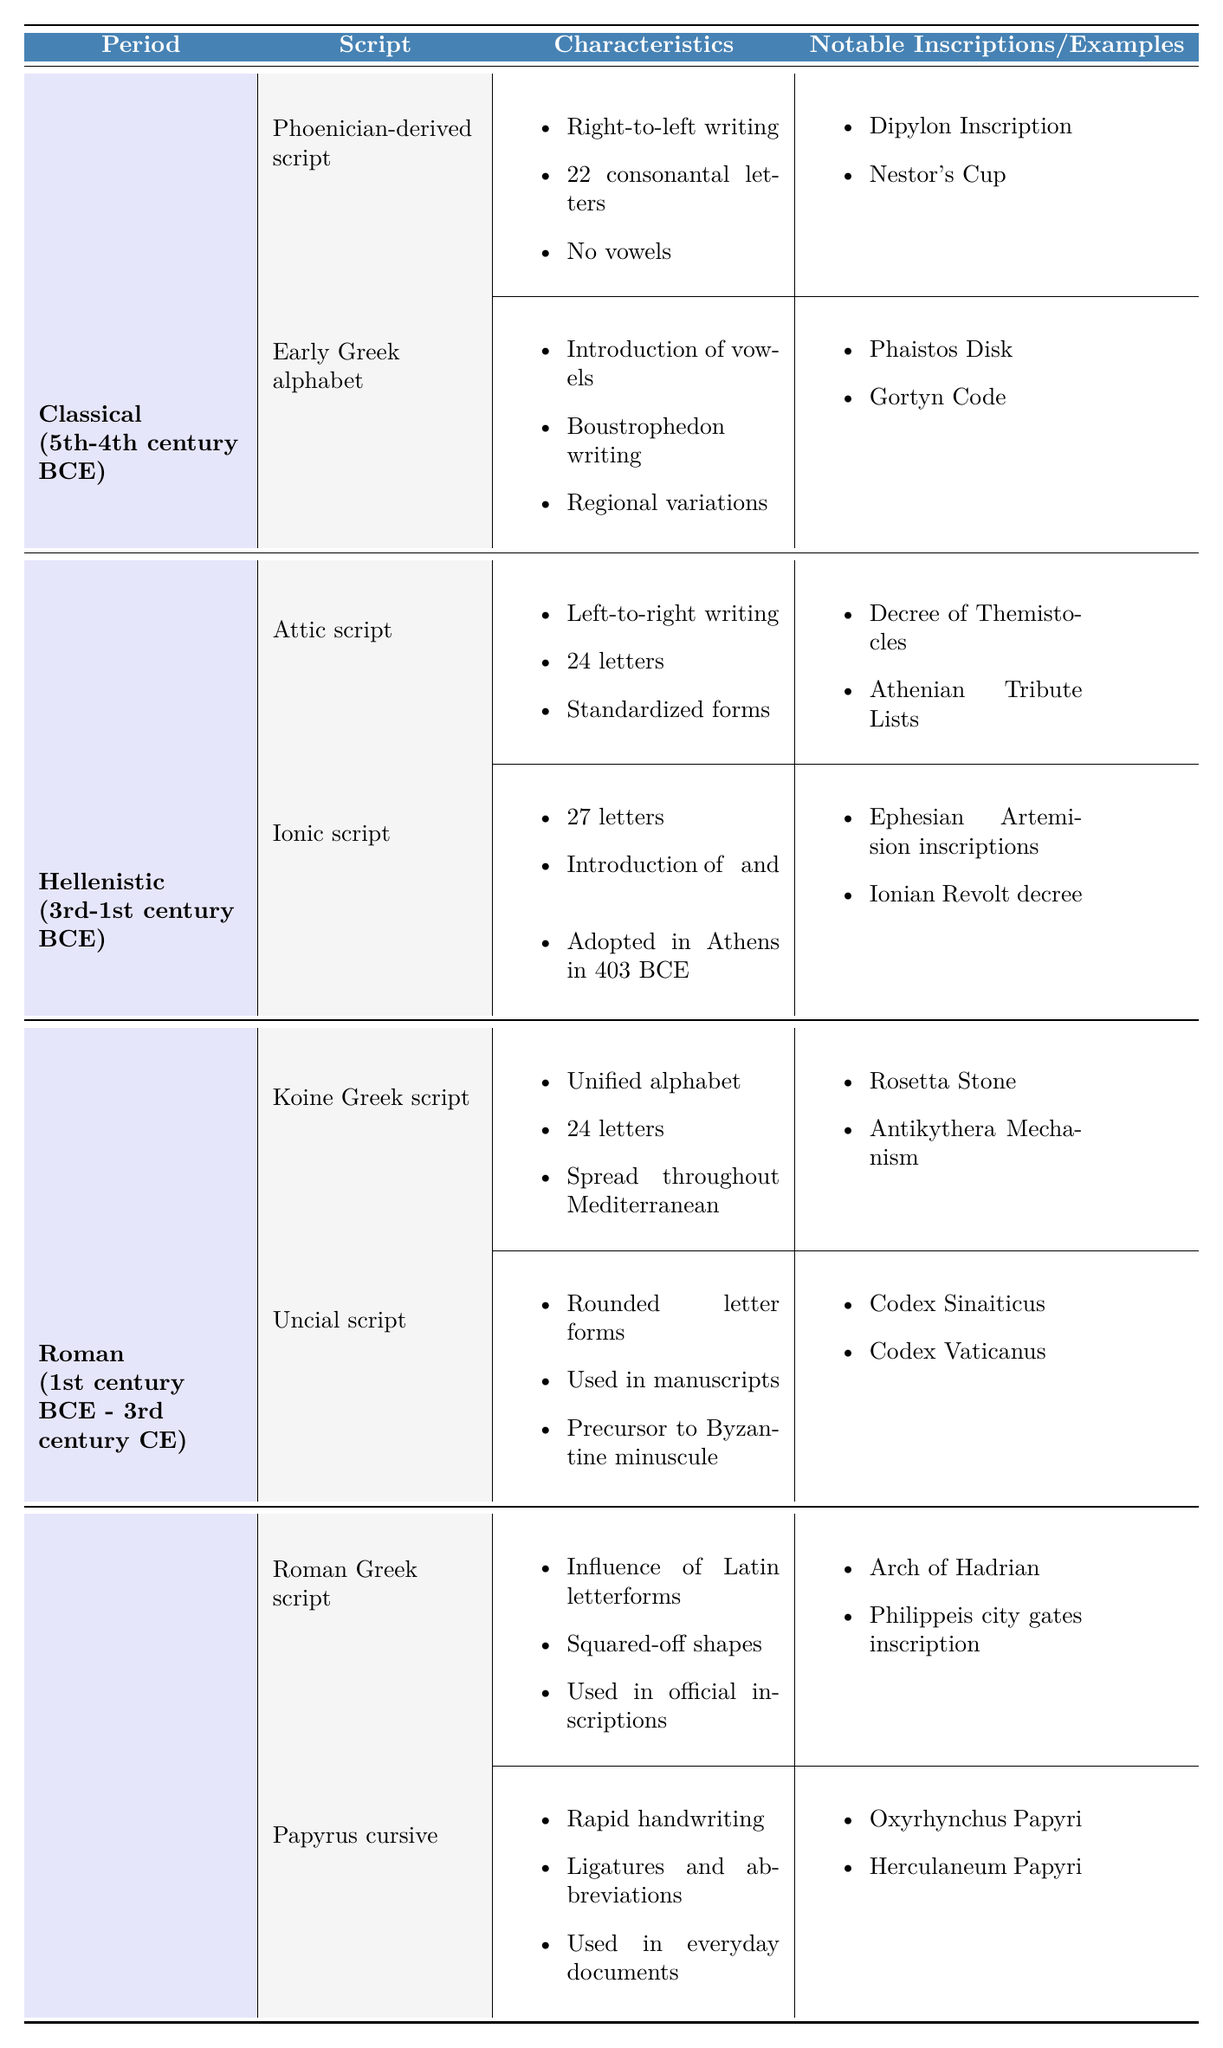What is the period for the "Ionic script"? The table lists the "Ionic script" under the "Classical (5th-4th century BCE)" period.
Answer: Classical (5th-4th century BCE) Which script introduced vowels? The "Early Greek alphabet" is noted for introducing vowels in its writing system.
Answer: Early Greek alphabet How many letters does the "Attic script" have? The table indicates that the "Attic script" consists of 24 letters.
Answer: 24 letters What are two notable inscriptions from the Hellenistic period? Notable inscriptions from the Hellenistic period include the "Rosetta Stone" and the "Antikythera Mechanism."
Answer: Rosetta Stone, Antikythera Mechanism Is the "Uncial script" a precursor to the Byzantine minuscule? The table states that the "Uncial script" is indeed a precursor to the Byzantine minuscule.
Answer: Yes How many total scripts are listed under the Archaic period? The Archaic period lists two scripts: "Phoenician-derived script" and "Early Greek alphabet." Thus, the total is 2.
Answer: 2 What type of writing direction did the "Phoenician-derived script" use? The "Phoenician-derived script" is characterized by right-to-left writing.
Answer: Right-to-left Which script was adopted in Athens in 403 BCE? The table indicates that the "Ionic script" was adopted in Athens in 403 BCE.
Answer: Ionic script What is the main characteristic of the "Papyrus cursive"? The "Papyrus cursive" is noted for its rapid handwriting, involving ligatures and abbreviations.
Answer: Rapid handwriting How many scripts are mentioned in the entire table? The table lists a total of eight scripts across the four periods (2 Archaic, 2 Classical, 2 Hellenistic, 2 Roman).
Answer: 8 scripts Which period has a script that spread throughout the Mediterranean? The "Koine Greek script," which has a unified alphabet, is from the Hellenistic period and spread throughout the Mediterranean.
Answer: Hellenistic What was the influence of Latin letterforms on the Roman Greek script? The "Roman Greek script" is characterized by the influence of Latin letterforms, resulting in squared-off shapes.
Answer: Influence of Latin letterforms How did the number of letters change from the "Early Greek alphabet" to "Ionic script"? The "Early Greek alphabet" included fewer than 27 letters (specific number not provided), while the "Ionic script" has 27 letters, indicating an increase in the number of letters.
Answer: Increased Is there a script that specifically mentions use in manuscripts? Yes, the "Uncial script" is noted for being used in manuscripts.
Answer: Yes What notable examples are associated with the "Papyrus cursive"? The table lists "Oxyrhynchus Papyri" and "Herculaneum Papyri" as notable examples of the "Papyrus cursive."
Answer: Oxyrhynchus Papyri, Herculaneum Papyri 